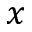Convert formula to latex. <formula><loc_0><loc_0><loc_500><loc_500>x</formula> 